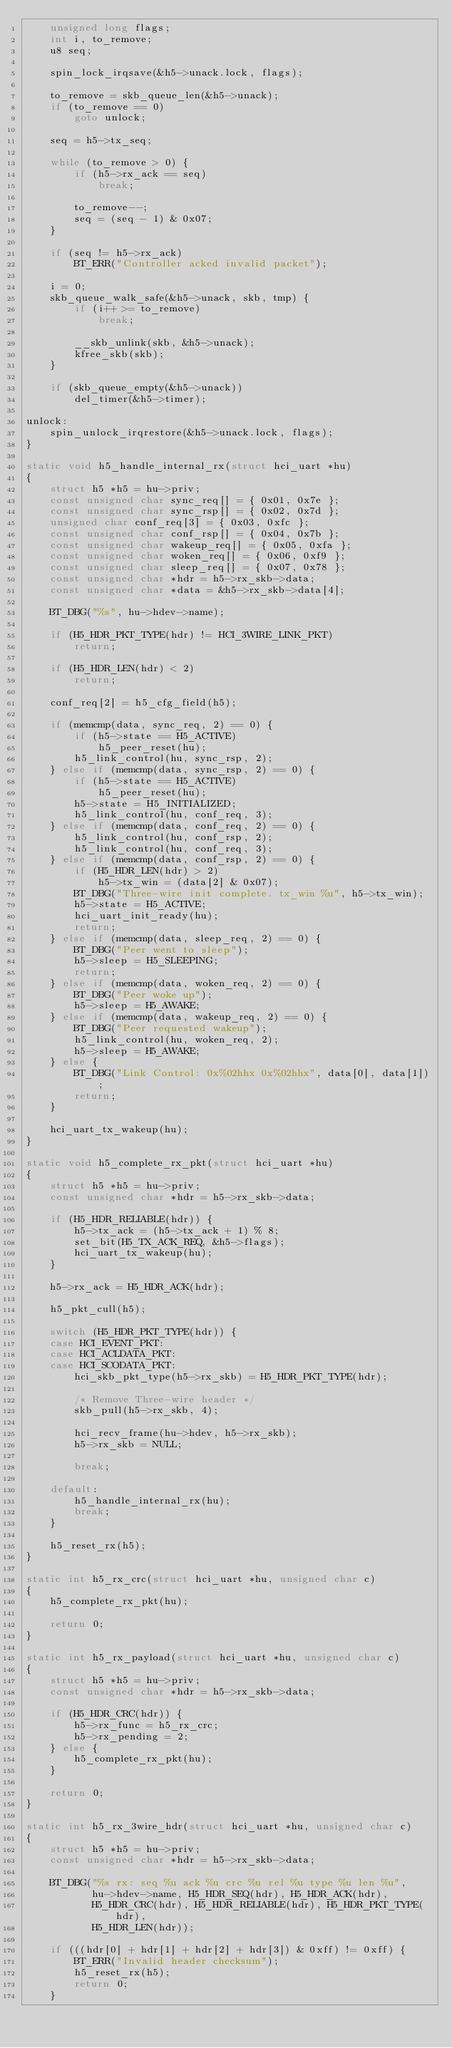<code> <loc_0><loc_0><loc_500><loc_500><_C_>	unsigned long flags;
	int i, to_remove;
	u8 seq;

	spin_lock_irqsave(&h5->unack.lock, flags);

	to_remove = skb_queue_len(&h5->unack);
	if (to_remove == 0)
		goto unlock;

	seq = h5->tx_seq;

	while (to_remove > 0) {
		if (h5->rx_ack == seq)
			break;

		to_remove--;
		seq = (seq - 1) & 0x07;
	}

	if (seq != h5->rx_ack)
		BT_ERR("Controller acked invalid packet");

	i = 0;
	skb_queue_walk_safe(&h5->unack, skb, tmp) {
		if (i++ >= to_remove)
			break;

		__skb_unlink(skb, &h5->unack);
		kfree_skb(skb);
	}

	if (skb_queue_empty(&h5->unack))
		del_timer(&h5->timer);

unlock:
	spin_unlock_irqrestore(&h5->unack.lock, flags);
}

static void h5_handle_internal_rx(struct hci_uart *hu)
{
	struct h5 *h5 = hu->priv;
	const unsigned char sync_req[] = { 0x01, 0x7e };
	const unsigned char sync_rsp[] = { 0x02, 0x7d };
	unsigned char conf_req[3] = { 0x03, 0xfc };
	const unsigned char conf_rsp[] = { 0x04, 0x7b };
	const unsigned char wakeup_req[] = { 0x05, 0xfa };
	const unsigned char woken_req[] = { 0x06, 0xf9 };
	const unsigned char sleep_req[] = { 0x07, 0x78 };
	const unsigned char *hdr = h5->rx_skb->data;
	const unsigned char *data = &h5->rx_skb->data[4];

	BT_DBG("%s", hu->hdev->name);

	if (H5_HDR_PKT_TYPE(hdr) != HCI_3WIRE_LINK_PKT)
		return;

	if (H5_HDR_LEN(hdr) < 2)
		return;

	conf_req[2] = h5_cfg_field(h5);

	if (memcmp(data, sync_req, 2) == 0) {
		if (h5->state == H5_ACTIVE)
			h5_peer_reset(hu);
		h5_link_control(hu, sync_rsp, 2);
	} else if (memcmp(data, sync_rsp, 2) == 0) {
		if (h5->state == H5_ACTIVE)
			h5_peer_reset(hu);
		h5->state = H5_INITIALIZED;
		h5_link_control(hu, conf_req, 3);
	} else if (memcmp(data, conf_req, 2) == 0) {
		h5_link_control(hu, conf_rsp, 2);
		h5_link_control(hu, conf_req, 3);
	} else if (memcmp(data, conf_rsp, 2) == 0) {
		if (H5_HDR_LEN(hdr) > 2)
			h5->tx_win = (data[2] & 0x07);
		BT_DBG("Three-wire init complete. tx_win %u", h5->tx_win);
		h5->state = H5_ACTIVE;
		hci_uart_init_ready(hu);
		return;
	} else if (memcmp(data, sleep_req, 2) == 0) {
		BT_DBG("Peer went to sleep");
		h5->sleep = H5_SLEEPING;
		return;
	} else if (memcmp(data, woken_req, 2) == 0) {
		BT_DBG("Peer woke up");
		h5->sleep = H5_AWAKE;
	} else if (memcmp(data, wakeup_req, 2) == 0) {
		BT_DBG("Peer requested wakeup");
		h5_link_control(hu, woken_req, 2);
		h5->sleep = H5_AWAKE;
	} else {
		BT_DBG("Link Control: 0x%02hhx 0x%02hhx", data[0], data[1]);
		return;
	}

	hci_uart_tx_wakeup(hu);
}

static void h5_complete_rx_pkt(struct hci_uart *hu)
{
	struct h5 *h5 = hu->priv;
	const unsigned char *hdr = h5->rx_skb->data;

	if (H5_HDR_RELIABLE(hdr)) {
		h5->tx_ack = (h5->tx_ack + 1) % 8;
		set_bit(H5_TX_ACK_REQ, &h5->flags);
		hci_uart_tx_wakeup(hu);
	}

	h5->rx_ack = H5_HDR_ACK(hdr);

	h5_pkt_cull(h5);

	switch (H5_HDR_PKT_TYPE(hdr)) {
	case HCI_EVENT_PKT:
	case HCI_ACLDATA_PKT:
	case HCI_SCODATA_PKT:
		hci_skb_pkt_type(h5->rx_skb) = H5_HDR_PKT_TYPE(hdr);

		/* Remove Three-wire header */
		skb_pull(h5->rx_skb, 4);

		hci_recv_frame(hu->hdev, h5->rx_skb);
		h5->rx_skb = NULL;

		break;

	default:
		h5_handle_internal_rx(hu);
		break;
	}

	h5_reset_rx(h5);
}

static int h5_rx_crc(struct hci_uart *hu, unsigned char c)
{
	h5_complete_rx_pkt(hu);

	return 0;
}

static int h5_rx_payload(struct hci_uart *hu, unsigned char c)
{
	struct h5 *h5 = hu->priv;
	const unsigned char *hdr = h5->rx_skb->data;

	if (H5_HDR_CRC(hdr)) {
		h5->rx_func = h5_rx_crc;
		h5->rx_pending = 2;
	} else {
		h5_complete_rx_pkt(hu);
	}

	return 0;
}

static int h5_rx_3wire_hdr(struct hci_uart *hu, unsigned char c)
{
	struct h5 *h5 = hu->priv;
	const unsigned char *hdr = h5->rx_skb->data;

	BT_DBG("%s rx: seq %u ack %u crc %u rel %u type %u len %u",
	       hu->hdev->name, H5_HDR_SEQ(hdr), H5_HDR_ACK(hdr),
	       H5_HDR_CRC(hdr), H5_HDR_RELIABLE(hdr), H5_HDR_PKT_TYPE(hdr),
	       H5_HDR_LEN(hdr));

	if (((hdr[0] + hdr[1] + hdr[2] + hdr[3]) & 0xff) != 0xff) {
		BT_ERR("Invalid header checksum");
		h5_reset_rx(h5);
		return 0;
	}
</code> 